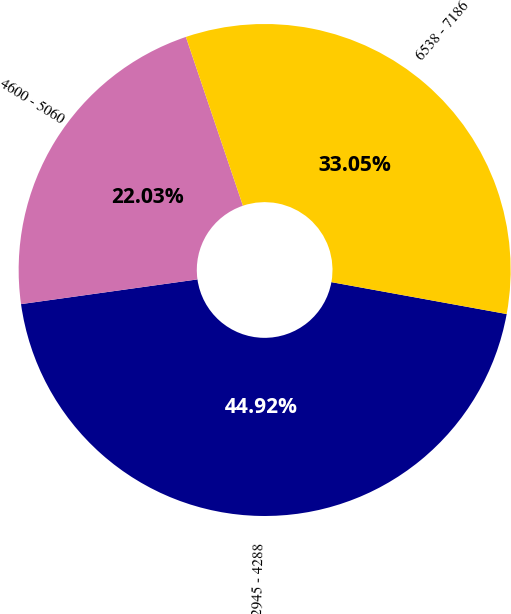Convert chart to OTSL. <chart><loc_0><loc_0><loc_500><loc_500><pie_chart><fcel>2945 - 4288<fcel>4600 - 5060<fcel>6538 - 7186<nl><fcel>44.92%<fcel>22.03%<fcel>33.05%<nl></chart> 